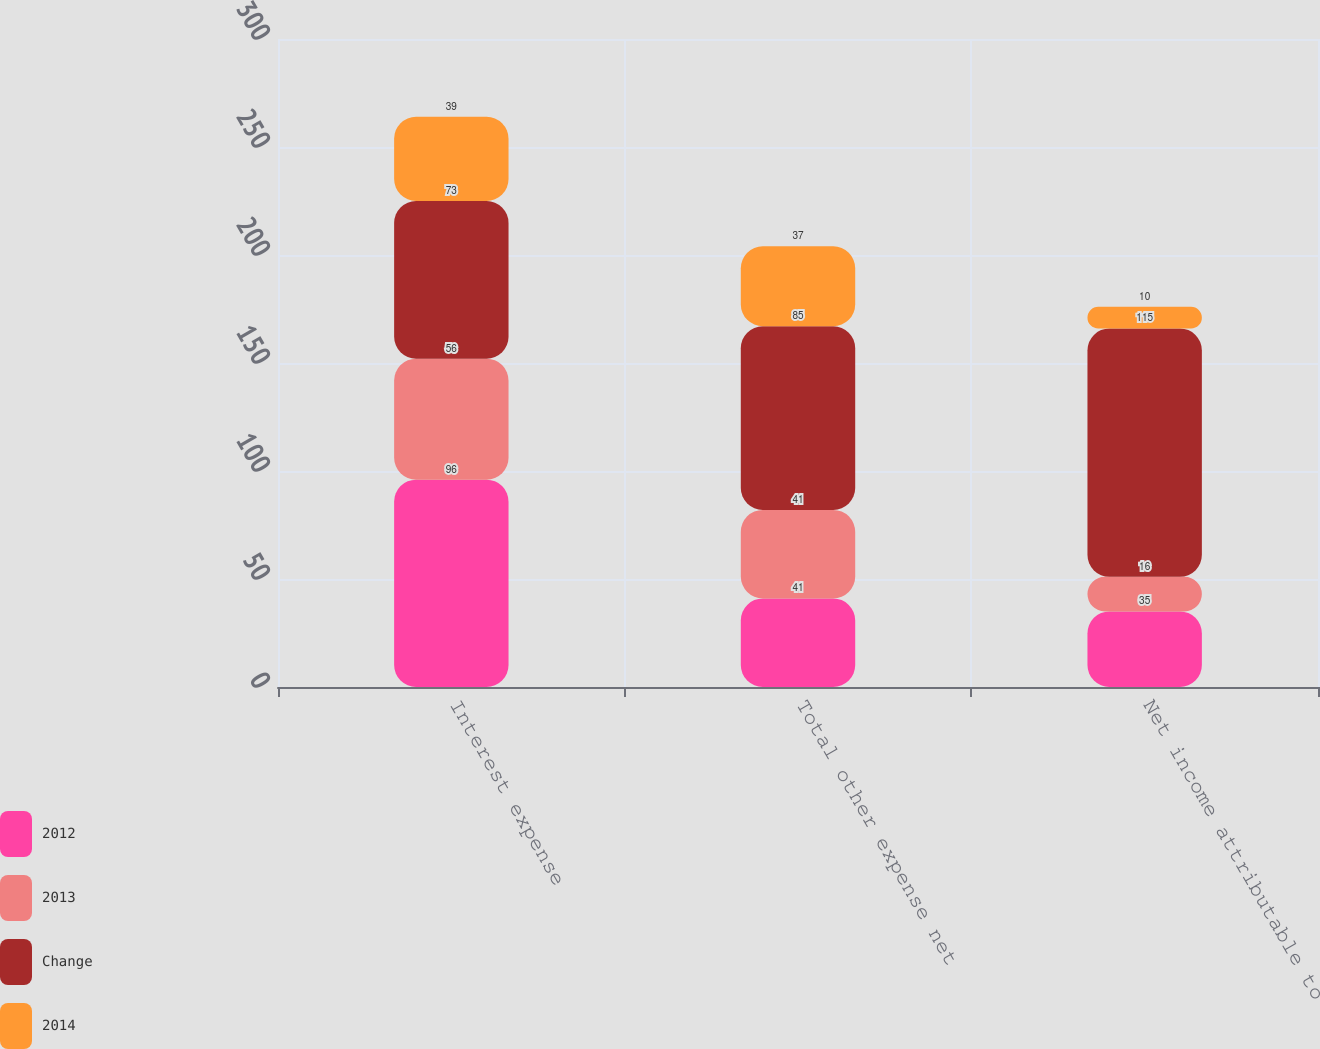Convert chart to OTSL. <chart><loc_0><loc_0><loc_500><loc_500><stacked_bar_chart><ecel><fcel>Interest expense<fcel>Total other expense net<fcel>Net income attributable to<nl><fcel>2012<fcel>96<fcel>41<fcel>35<nl><fcel>2013<fcel>56<fcel>41<fcel>16<nl><fcel>Change<fcel>73<fcel>85<fcel>115<nl><fcel>2014<fcel>39<fcel>37<fcel>10<nl></chart> 